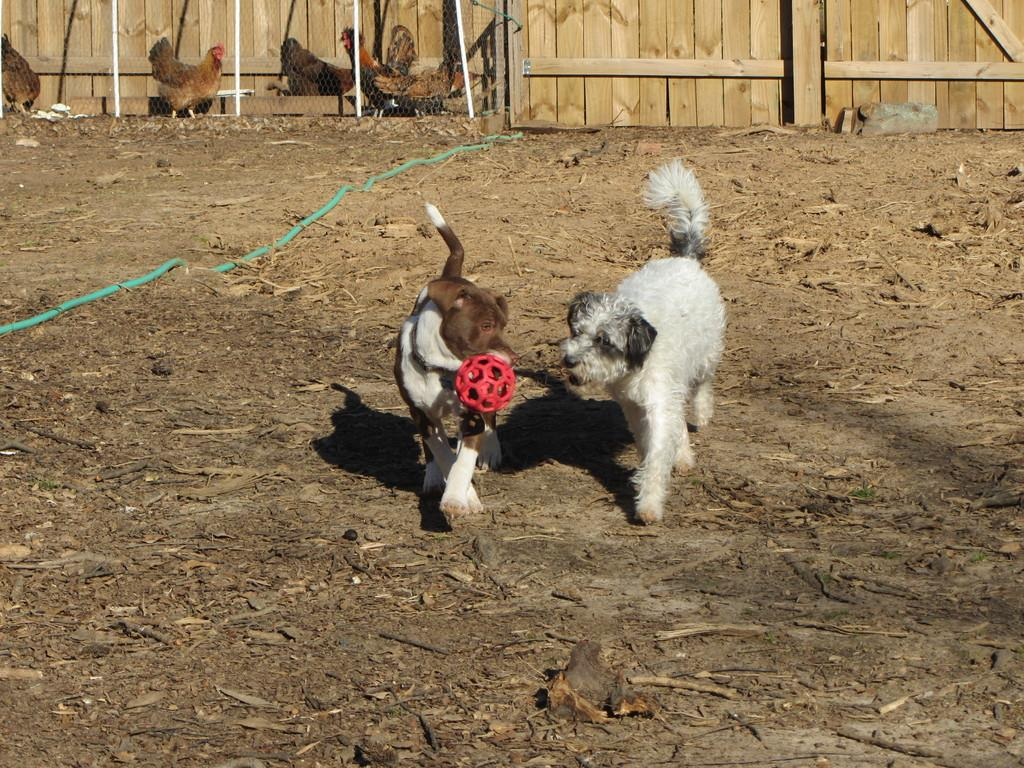What type of animals are in the image? There are dogs in the image. Where are the dogs located? The dogs are on a land in the image. What other animals can be seen in the background of the image? There are hens in the background of the image. What type of land is visible in the image? There is a wooden land in the image. What type of ear is visible on the dogs in the image? The image does not show the dogs' ears, so it is not possible to determine the type of ear. 